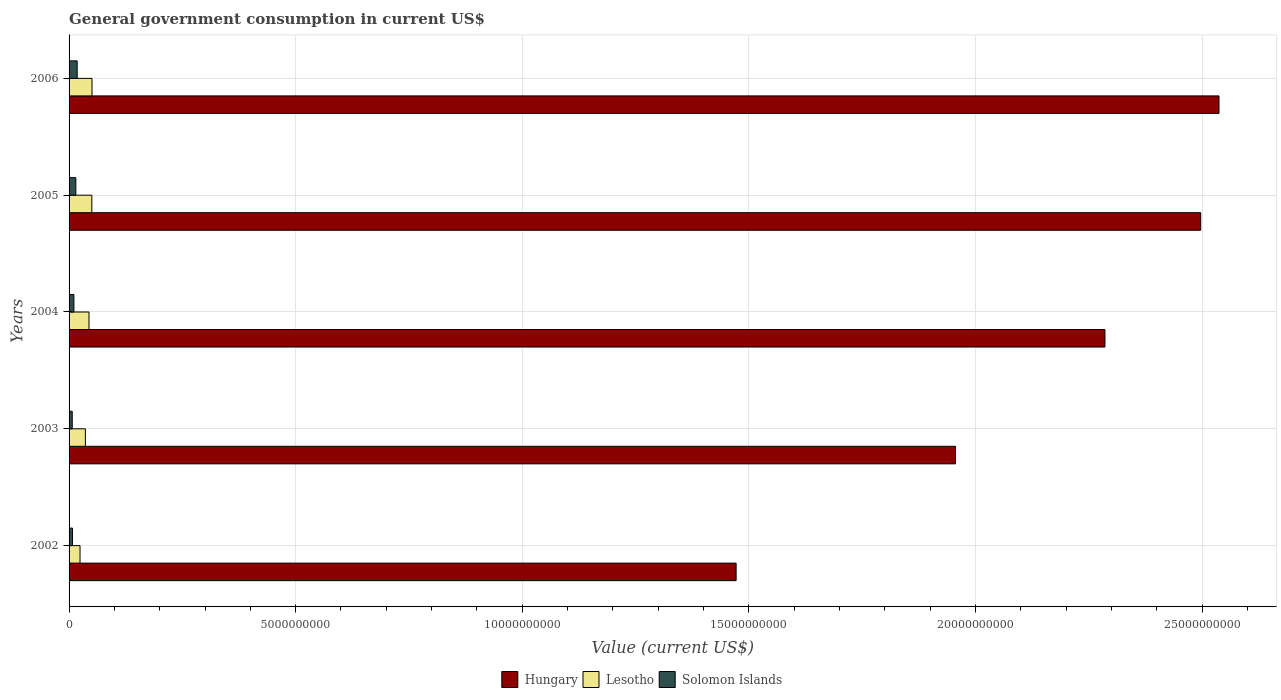How many different coloured bars are there?
Offer a very short reply. 3. How many groups of bars are there?
Offer a very short reply. 5. How many bars are there on the 4th tick from the bottom?
Ensure brevity in your answer.  3. In how many cases, is the number of bars for a given year not equal to the number of legend labels?
Give a very brief answer. 0. What is the government conusmption in Solomon Islands in 2004?
Provide a succinct answer. 1.07e+08. Across all years, what is the maximum government conusmption in Hungary?
Provide a short and direct response. 2.54e+1. Across all years, what is the minimum government conusmption in Lesotho?
Ensure brevity in your answer.  2.42e+08. What is the total government conusmption in Lesotho in the graph?
Give a very brief answer. 2.05e+09. What is the difference between the government conusmption in Solomon Islands in 2002 and that in 2006?
Ensure brevity in your answer.  -1.04e+08. What is the difference between the government conusmption in Hungary in 2006 and the government conusmption in Solomon Islands in 2002?
Your answer should be compact. 2.53e+1. What is the average government conusmption in Solomon Islands per year?
Offer a very short reply. 1.16e+08. In the year 2004, what is the difference between the government conusmption in Hungary and government conusmption in Solomon Islands?
Your response must be concise. 2.28e+1. In how many years, is the government conusmption in Hungary greater than 23000000000 US$?
Your response must be concise. 2. What is the ratio of the government conusmption in Hungary in 2002 to that in 2004?
Give a very brief answer. 0.64. Is the government conusmption in Hungary in 2003 less than that in 2005?
Your answer should be compact. Yes. What is the difference between the highest and the second highest government conusmption in Solomon Islands?
Make the answer very short. 2.98e+07. What is the difference between the highest and the lowest government conusmption in Hungary?
Your response must be concise. 1.07e+1. What does the 2nd bar from the top in 2006 represents?
Your answer should be compact. Lesotho. What does the 2nd bar from the bottom in 2002 represents?
Make the answer very short. Lesotho. How many years are there in the graph?
Make the answer very short. 5. What is the difference between two consecutive major ticks on the X-axis?
Provide a succinct answer. 5.00e+09. Does the graph contain any zero values?
Provide a short and direct response. No. Does the graph contain grids?
Your response must be concise. Yes. What is the title of the graph?
Make the answer very short. General government consumption in current US$. What is the label or title of the X-axis?
Your answer should be compact. Value (current US$). What is the label or title of the Y-axis?
Offer a terse response. Years. What is the Value (current US$) in Hungary in 2002?
Your answer should be very brief. 1.47e+1. What is the Value (current US$) of Lesotho in 2002?
Your response must be concise. 2.42e+08. What is the Value (current US$) of Solomon Islands in 2002?
Offer a terse response. 7.49e+07. What is the Value (current US$) of Hungary in 2003?
Make the answer very short. 1.96e+1. What is the Value (current US$) of Lesotho in 2003?
Provide a short and direct response. 3.60e+08. What is the Value (current US$) in Solomon Islands in 2003?
Your answer should be compact. 6.99e+07. What is the Value (current US$) of Hungary in 2004?
Provide a short and direct response. 2.29e+1. What is the Value (current US$) of Lesotho in 2004?
Your response must be concise. 4.40e+08. What is the Value (current US$) of Solomon Islands in 2004?
Your answer should be compact. 1.07e+08. What is the Value (current US$) in Hungary in 2005?
Offer a very short reply. 2.50e+1. What is the Value (current US$) of Lesotho in 2005?
Provide a short and direct response. 5.02e+08. What is the Value (current US$) of Solomon Islands in 2005?
Offer a very short reply. 1.49e+08. What is the Value (current US$) of Hungary in 2006?
Give a very brief answer. 2.54e+1. What is the Value (current US$) in Lesotho in 2006?
Make the answer very short. 5.06e+08. What is the Value (current US$) of Solomon Islands in 2006?
Your answer should be compact. 1.79e+08. Across all years, what is the maximum Value (current US$) in Hungary?
Provide a succinct answer. 2.54e+1. Across all years, what is the maximum Value (current US$) in Lesotho?
Provide a short and direct response. 5.06e+08. Across all years, what is the maximum Value (current US$) of Solomon Islands?
Offer a terse response. 1.79e+08. Across all years, what is the minimum Value (current US$) of Hungary?
Offer a very short reply. 1.47e+1. Across all years, what is the minimum Value (current US$) in Lesotho?
Provide a succinct answer. 2.42e+08. Across all years, what is the minimum Value (current US$) in Solomon Islands?
Offer a very short reply. 6.99e+07. What is the total Value (current US$) in Hungary in the graph?
Your response must be concise. 1.07e+11. What is the total Value (current US$) in Lesotho in the graph?
Provide a succinct answer. 2.05e+09. What is the total Value (current US$) of Solomon Islands in the graph?
Give a very brief answer. 5.80e+08. What is the difference between the Value (current US$) of Hungary in 2002 and that in 2003?
Your answer should be very brief. -4.84e+09. What is the difference between the Value (current US$) in Lesotho in 2002 and that in 2003?
Keep it short and to the point. -1.18e+08. What is the difference between the Value (current US$) of Solomon Islands in 2002 and that in 2003?
Your answer should be compact. 5.00e+06. What is the difference between the Value (current US$) of Hungary in 2002 and that in 2004?
Offer a terse response. -8.14e+09. What is the difference between the Value (current US$) of Lesotho in 2002 and that in 2004?
Ensure brevity in your answer.  -1.98e+08. What is the difference between the Value (current US$) in Solomon Islands in 2002 and that in 2004?
Your response must be concise. -3.22e+07. What is the difference between the Value (current US$) in Hungary in 2002 and that in 2005?
Your response must be concise. -1.03e+1. What is the difference between the Value (current US$) of Lesotho in 2002 and that in 2005?
Provide a short and direct response. -2.60e+08. What is the difference between the Value (current US$) in Solomon Islands in 2002 and that in 2005?
Offer a terse response. -7.43e+07. What is the difference between the Value (current US$) of Hungary in 2002 and that in 2006?
Give a very brief answer. -1.07e+1. What is the difference between the Value (current US$) of Lesotho in 2002 and that in 2006?
Keep it short and to the point. -2.64e+08. What is the difference between the Value (current US$) in Solomon Islands in 2002 and that in 2006?
Offer a terse response. -1.04e+08. What is the difference between the Value (current US$) of Hungary in 2003 and that in 2004?
Your response must be concise. -3.30e+09. What is the difference between the Value (current US$) of Lesotho in 2003 and that in 2004?
Keep it short and to the point. -7.94e+07. What is the difference between the Value (current US$) of Solomon Islands in 2003 and that in 2004?
Ensure brevity in your answer.  -3.72e+07. What is the difference between the Value (current US$) in Hungary in 2003 and that in 2005?
Offer a very short reply. -5.41e+09. What is the difference between the Value (current US$) of Lesotho in 2003 and that in 2005?
Provide a short and direct response. -1.42e+08. What is the difference between the Value (current US$) of Solomon Islands in 2003 and that in 2005?
Provide a short and direct response. -7.93e+07. What is the difference between the Value (current US$) in Hungary in 2003 and that in 2006?
Your answer should be very brief. -5.81e+09. What is the difference between the Value (current US$) of Lesotho in 2003 and that in 2006?
Your response must be concise. -1.46e+08. What is the difference between the Value (current US$) of Solomon Islands in 2003 and that in 2006?
Your response must be concise. -1.09e+08. What is the difference between the Value (current US$) of Hungary in 2004 and that in 2005?
Your response must be concise. -2.11e+09. What is the difference between the Value (current US$) in Lesotho in 2004 and that in 2005?
Keep it short and to the point. -6.25e+07. What is the difference between the Value (current US$) in Solomon Islands in 2004 and that in 2005?
Your answer should be compact. -4.21e+07. What is the difference between the Value (current US$) in Hungary in 2004 and that in 2006?
Offer a very short reply. -2.52e+09. What is the difference between the Value (current US$) in Lesotho in 2004 and that in 2006?
Offer a terse response. -6.62e+07. What is the difference between the Value (current US$) of Solomon Islands in 2004 and that in 2006?
Offer a terse response. -7.19e+07. What is the difference between the Value (current US$) of Hungary in 2005 and that in 2006?
Offer a very short reply. -4.04e+08. What is the difference between the Value (current US$) in Lesotho in 2005 and that in 2006?
Provide a short and direct response. -3.74e+06. What is the difference between the Value (current US$) in Solomon Islands in 2005 and that in 2006?
Offer a very short reply. -2.98e+07. What is the difference between the Value (current US$) in Hungary in 2002 and the Value (current US$) in Lesotho in 2003?
Offer a terse response. 1.44e+1. What is the difference between the Value (current US$) of Hungary in 2002 and the Value (current US$) of Solomon Islands in 2003?
Your answer should be very brief. 1.46e+1. What is the difference between the Value (current US$) in Lesotho in 2002 and the Value (current US$) in Solomon Islands in 2003?
Offer a very short reply. 1.72e+08. What is the difference between the Value (current US$) in Hungary in 2002 and the Value (current US$) in Lesotho in 2004?
Offer a terse response. 1.43e+1. What is the difference between the Value (current US$) in Hungary in 2002 and the Value (current US$) in Solomon Islands in 2004?
Provide a short and direct response. 1.46e+1. What is the difference between the Value (current US$) in Lesotho in 2002 and the Value (current US$) in Solomon Islands in 2004?
Your answer should be very brief. 1.35e+08. What is the difference between the Value (current US$) of Hungary in 2002 and the Value (current US$) of Lesotho in 2005?
Ensure brevity in your answer.  1.42e+1. What is the difference between the Value (current US$) in Hungary in 2002 and the Value (current US$) in Solomon Islands in 2005?
Keep it short and to the point. 1.46e+1. What is the difference between the Value (current US$) of Lesotho in 2002 and the Value (current US$) of Solomon Islands in 2005?
Your answer should be very brief. 9.25e+07. What is the difference between the Value (current US$) in Hungary in 2002 and the Value (current US$) in Lesotho in 2006?
Keep it short and to the point. 1.42e+1. What is the difference between the Value (current US$) in Hungary in 2002 and the Value (current US$) in Solomon Islands in 2006?
Your answer should be very brief. 1.45e+1. What is the difference between the Value (current US$) in Lesotho in 2002 and the Value (current US$) in Solomon Islands in 2006?
Your answer should be compact. 6.27e+07. What is the difference between the Value (current US$) of Hungary in 2003 and the Value (current US$) of Lesotho in 2004?
Your answer should be compact. 1.91e+1. What is the difference between the Value (current US$) of Hungary in 2003 and the Value (current US$) of Solomon Islands in 2004?
Give a very brief answer. 1.95e+1. What is the difference between the Value (current US$) of Lesotho in 2003 and the Value (current US$) of Solomon Islands in 2004?
Your answer should be very brief. 2.53e+08. What is the difference between the Value (current US$) of Hungary in 2003 and the Value (current US$) of Lesotho in 2005?
Give a very brief answer. 1.91e+1. What is the difference between the Value (current US$) of Hungary in 2003 and the Value (current US$) of Solomon Islands in 2005?
Provide a succinct answer. 1.94e+1. What is the difference between the Value (current US$) in Lesotho in 2003 and the Value (current US$) in Solomon Islands in 2005?
Your answer should be very brief. 2.11e+08. What is the difference between the Value (current US$) of Hungary in 2003 and the Value (current US$) of Lesotho in 2006?
Your answer should be very brief. 1.91e+1. What is the difference between the Value (current US$) of Hungary in 2003 and the Value (current US$) of Solomon Islands in 2006?
Your answer should be very brief. 1.94e+1. What is the difference between the Value (current US$) in Lesotho in 2003 and the Value (current US$) in Solomon Islands in 2006?
Offer a very short reply. 1.81e+08. What is the difference between the Value (current US$) in Hungary in 2004 and the Value (current US$) in Lesotho in 2005?
Offer a terse response. 2.24e+1. What is the difference between the Value (current US$) of Hungary in 2004 and the Value (current US$) of Solomon Islands in 2005?
Your answer should be compact. 2.27e+1. What is the difference between the Value (current US$) of Lesotho in 2004 and the Value (current US$) of Solomon Islands in 2005?
Give a very brief answer. 2.90e+08. What is the difference between the Value (current US$) in Hungary in 2004 and the Value (current US$) in Lesotho in 2006?
Provide a short and direct response. 2.24e+1. What is the difference between the Value (current US$) in Hungary in 2004 and the Value (current US$) in Solomon Islands in 2006?
Offer a terse response. 2.27e+1. What is the difference between the Value (current US$) in Lesotho in 2004 and the Value (current US$) in Solomon Islands in 2006?
Give a very brief answer. 2.61e+08. What is the difference between the Value (current US$) of Hungary in 2005 and the Value (current US$) of Lesotho in 2006?
Your response must be concise. 2.45e+1. What is the difference between the Value (current US$) of Hungary in 2005 and the Value (current US$) of Solomon Islands in 2006?
Provide a succinct answer. 2.48e+1. What is the difference between the Value (current US$) of Lesotho in 2005 and the Value (current US$) of Solomon Islands in 2006?
Make the answer very short. 3.23e+08. What is the average Value (current US$) of Hungary per year?
Ensure brevity in your answer.  2.15e+1. What is the average Value (current US$) of Lesotho per year?
Keep it short and to the point. 4.10e+08. What is the average Value (current US$) in Solomon Islands per year?
Your answer should be very brief. 1.16e+08. In the year 2002, what is the difference between the Value (current US$) of Hungary and Value (current US$) of Lesotho?
Make the answer very short. 1.45e+1. In the year 2002, what is the difference between the Value (current US$) of Hungary and Value (current US$) of Solomon Islands?
Your answer should be compact. 1.46e+1. In the year 2002, what is the difference between the Value (current US$) in Lesotho and Value (current US$) in Solomon Islands?
Offer a terse response. 1.67e+08. In the year 2003, what is the difference between the Value (current US$) of Hungary and Value (current US$) of Lesotho?
Make the answer very short. 1.92e+1. In the year 2003, what is the difference between the Value (current US$) of Hungary and Value (current US$) of Solomon Islands?
Your answer should be very brief. 1.95e+1. In the year 2003, what is the difference between the Value (current US$) of Lesotho and Value (current US$) of Solomon Islands?
Offer a terse response. 2.90e+08. In the year 2004, what is the difference between the Value (current US$) in Hungary and Value (current US$) in Lesotho?
Your answer should be compact. 2.24e+1. In the year 2004, what is the difference between the Value (current US$) of Hungary and Value (current US$) of Solomon Islands?
Your response must be concise. 2.28e+1. In the year 2004, what is the difference between the Value (current US$) of Lesotho and Value (current US$) of Solomon Islands?
Offer a terse response. 3.33e+08. In the year 2005, what is the difference between the Value (current US$) in Hungary and Value (current US$) in Lesotho?
Your answer should be very brief. 2.45e+1. In the year 2005, what is the difference between the Value (current US$) in Hungary and Value (current US$) in Solomon Islands?
Offer a terse response. 2.48e+1. In the year 2005, what is the difference between the Value (current US$) in Lesotho and Value (current US$) in Solomon Islands?
Offer a terse response. 3.53e+08. In the year 2006, what is the difference between the Value (current US$) of Hungary and Value (current US$) of Lesotho?
Offer a very short reply. 2.49e+1. In the year 2006, what is the difference between the Value (current US$) in Hungary and Value (current US$) in Solomon Islands?
Give a very brief answer. 2.52e+1. In the year 2006, what is the difference between the Value (current US$) in Lesotho and Value (current US$) in Solomon Islands?
Offer a terse response. 3.27e+08. What is the ratio of the Value (current US$) in Hungary in 2002 to that in 2003?
Make the answer very short. 0.75. What is the ratio of the Value (current US$) of Lesotho in 2002 to that in 2003?
Give a very brief answer. 0.67. What is the ratio of the Value (current US$) in Solomon Islands in 2002 to that in 2003?
Your response must be concise. 1.07. What is the ratio of the Value (current US$) of Hungary in 2002 to that in 2004?
Offer a terse response. 0.64. What is the ratio of the Value (current US$) in Lesotho in 2002 to that in 2004?
Keep it short and to the point. 0.55. What is the ratio of the Value (current US$) in Solomon Islands in 2002 to that in 2004?
Keep it short and to the point. 0.7. What is the ratio of the Value (current US$) in Hungary in 2002 to that in 2005?
Your answer should be very brief. 0.59. What is the ratio of the Value (current US$) in Lesotho in 2002 to that in 2005?
Offer a terse response. 0.48. What is the ratio of the Value (current US$) of Solomon Islands in 2002 to that in 2005?
Ensure brevity in your answer.  0.5. What is the ratio of the Value (current US$) in Hungary in 2002 to that in 2006?
Offer a very short reply. 0.58. What is the ratio of the Value (current US$) in Lesotho in 2002 to that in 2006?
Your answer should be very brief. 0.48. What is the ratio of the Value (current US$) in Solomon Islands in 2002 to that in 2006?
Your response must be concise. 0.42. What is the ratio of the Value (current US$) of Hungary in 2003 to that in 2004?
Your response must be concise. 0.86. What is the ratio of the Value (current US$) in Lesotho in 2003 to that in 2004?
Give a very brief answer. 0.82. What is the ratio of the Value (current US$) of Solomon Islands in 2003 to that in 2004?
Offer a terse response. 0.65. What is the ratio of the Value (current US$) in Hungary in 2003 to that in 2005?
Ensure brevity in your answer.  0.78. What is the ratio of the Value (current US$) of Lesotho in 2003 to that in 2005?
Your answer should be very brief. 0.72. What is the ratio of the Value (current US$) in Solomon Islands in 2003 to that in 2005?
Make the answer very short. 0.47. What is the ratio of the Value (current US$) in Hungary in 2003 to that in 2006?
Your response must be concise. 0.77. What is the ratio of the Value (current US$) of Lesotho in 2003 to that in 2006?
Your response must be concise. 0.71. What is the ratio of the Value (current US$) in Solomon Islands in 2003 to that in 2006?
Give a very brief answer. 0.39. What is the ratio of the Value (current US$) in Hungary in 2004 to that in 2005?
Keep it short and to the point. 0.92. What is the ratio of the Value (current US$) in Lesotho in 2004 to that in 2005?
Your answer should be very brief. 0.88. What is the ratio of the Value (current US$) in Solomon Islands in 2004 to that in 2005?
Your answer should be very brief. 0.72. What is the ratio of the Value (current US$) in Hungary in 2004 to that in 2006?
Provide a succinct answer. 0.9. What is the ratio of the Value (current US$) in Lesotho in 2004 to that in 2006?
Make the answer very short. 0.87. What is the ratio of the Value (current US$) in Solomon Islands in 2004 to that in 2006?
Keep it short and to the point. 0.6. What is the ratio of the Value (current US$) of Hungary in 2005 to that in 2006?
Give a very brief answer. 0.98. What is the ratio of the Value (current US$) of Lesotho in 2005 to that in 2006?
Offer a very short reply. 0.99. What is the ratio of the Value (current US$) of Solomon Islands in 2005 to that in 2006?
Provide a succinct answer. 0.83. What is the difference between the highest and the second highest Value (current US$) of Hungary?
Make the answer very short. 4.04e+08. What is the difference between the highest and the second highest Value (current US$) in Lesotho?
Keep it short and to the point. 3.74e+06. What is the difference between the highest and the second highest Value (current US$) in Solomon Islands?
Your answer should be very brief. 2.98e+07. What is the difference between the highest and the lowest Value (current US$) of Hungary?
Provide a succinct answer. 1.07e+1. What is the difference between the highest and the lowest Value (current US$) of Lesotho?
Your answer should be very brief. 2.64e+08. What is the difference between the highest and the lowest Value (current US$) in Solomon Islands?
Keep it short and to the point. 1.09e+08. 